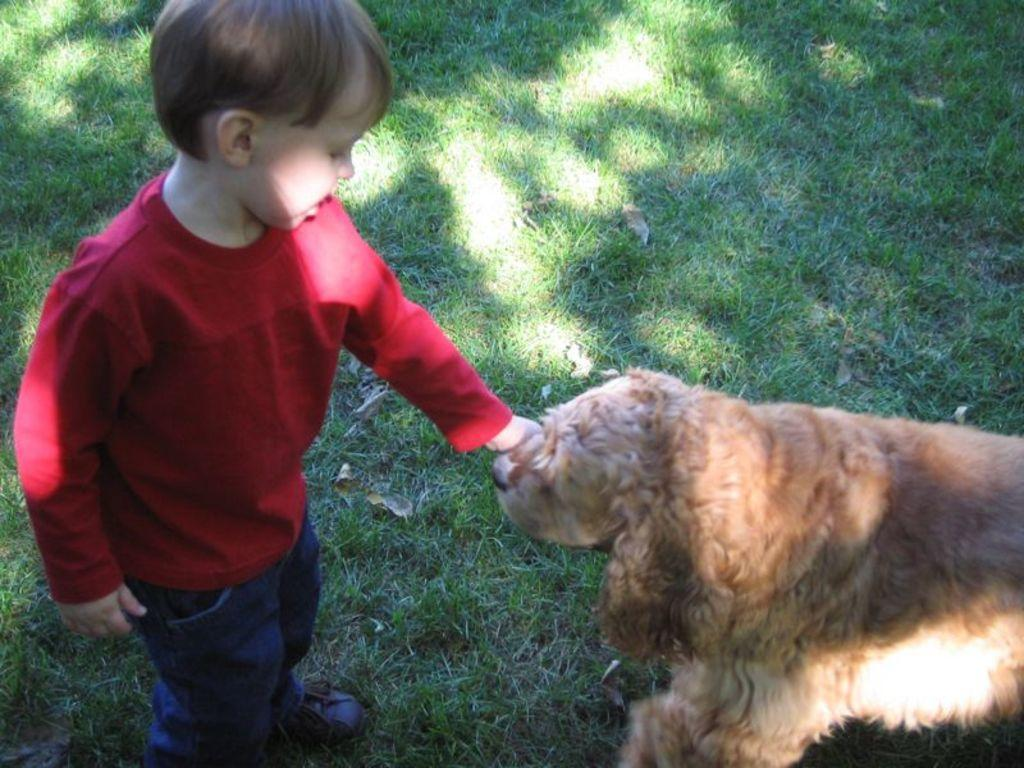What is the main subject of the image? There is a boy in the image. What is the boy doing in the image? The boy is catching a dog in the image. What can be seen in the background of the image? There is grass in the background of the image. What type of chair is the boy sitting on in the image? There is no chair present in the image; the boy is standing and catching a dog. 